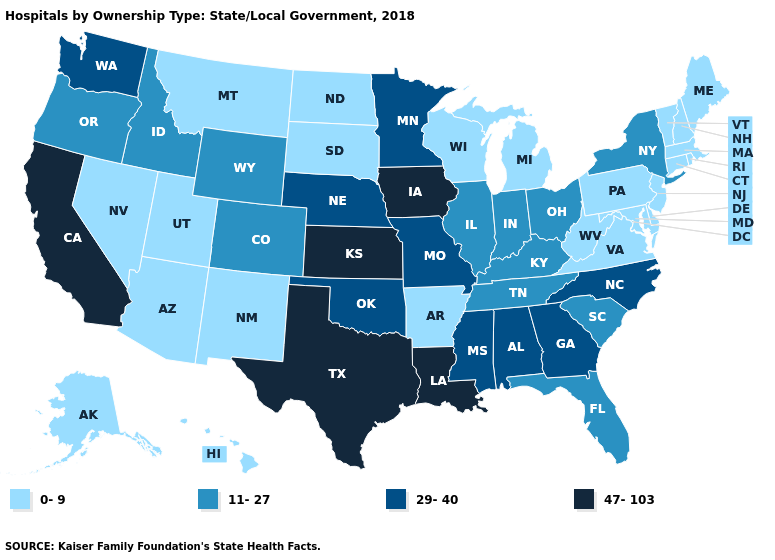What is the value of Washington?
Be succinct. 29-40. Among the states that border Texas , which have the highest value?
Answer briefly. Louisiana. How many symbols are there in the legend?
Short answer required. 4. Which states have the highest value in the USA?
Quick response, please. California, Iowa, Kansas, Louisiana, Texas. Which states hav the highest value in the South?
Keep it brief. Louisiana, Texas. Name the states that have a value in the range 11-27?
Write a very short answer. Colorado, Florida, Idaho, Illinois, Indiana, Kentucky, New York, Ohio, Oregon, South Carolina, Tennessee, Wyoming. Name the states that have a value in the range 29-40?
Answer briefly. Alabama, Georgia, Minnesota, Mississippi, Missouri, Nebraska, North Carolina, Oklahoma, Washington. Is the legend a continuous bar?
Give a very brief answer. No. Does Texas have the highest value in the USA?
Give a very brief answer. Yes. How many symbols are there in the legend?
Keep it brief. 4. Among the states that border Kansas , which have the highest value?
Answer briefly. Missouri, Nebraska, Oklahoma. Among the states that border Colorado , does Kansas have the highest value?
Write a very short answer. Yes. What is the value of Ohio?
Quick response, please. 11-27. Does the first symbol in the legend represent the smallest category?
Quick response, please. Yes. Does South Carolina have a lower value than Minnesota?
Keep it brief. Yes. 